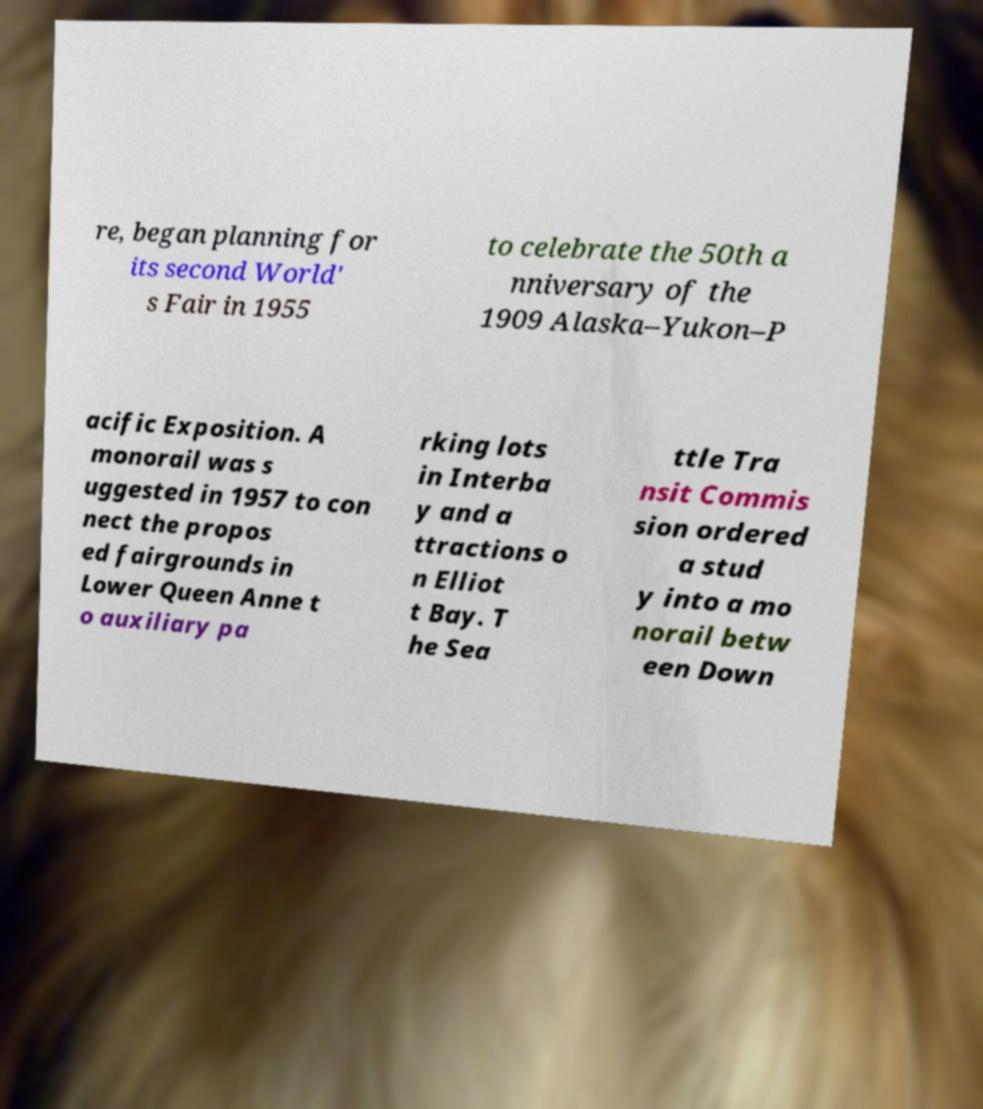Could you extract and type out the text from this image? re, began planning for its second World' s Fair in 1955 to celebrate the 50th a nniversary of the 1909 Alaska–Yukon–P acific Exposition. A monorail was s uggested in 1957 to con nect the propos ed fairgrounds in Lower Queen Anne t o auxiliary pa rking lots in Interba y and a ttractions o n Elliot t Bay. T he Sea ttle Tra nsit Commis sion ordered a stud y into a mo norail betw een Down 